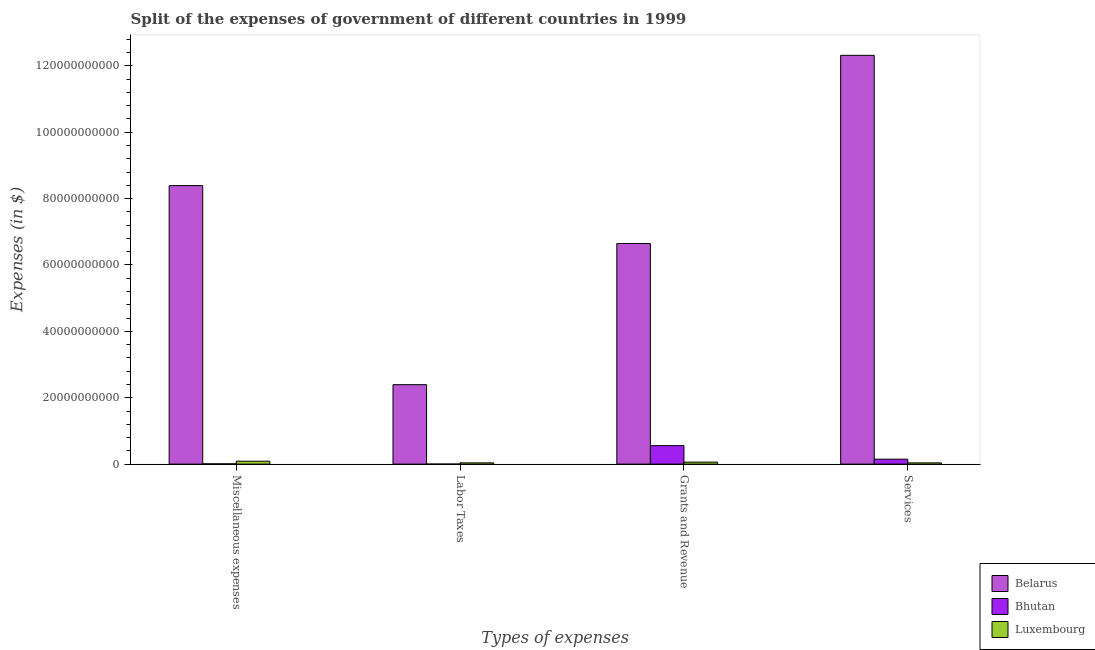How many groups of bars are there?
Provide a short and direct response. 4. Are the number of bars on each tick of the X-axis equal?
Make the answer very short. Yes. What is the label of the 2nd group of bars from the left?
Your answer should be very brief. Labor Taxes. What is the amount spent on grants and revenue in Luxembourg?
Ensure brevity in your answer.  5.98e+08. Across all countries, what is the maximum amount spent on labor taxes?
Keep it short and to the point. 2.39e+1. Across all countries, what is the minimum amount spent on grants and revenue?
Your response must be concise. 5.98e+08. In which country was the amount spent on labor taxes maximum?
Ensure brevity in your answer.  Belarus. In which country was the amount spent on grants and revenue minimum?
Ensure brevity in your answer.  Luxembourg. What is the total amount spent on services in the graph?
Offer a terse response. 1.25e+11. What is the difference between the amount spent on services in Belarus and that in Bhutan?
Keep it short and to the point. 1.22e+11. What is the difference between the amount spent on miscellaneous expenses in Bhutan and the amount spent on labor taxes in Luxembourg?
Make the answer very short. -2.91e+08. What is the average amount spent on labor taxes per country?
Offer a very short reply. 8.11e+09. What is the difference between the amount spent on grants and revenue and amount spent on miscellaneous expenses in Luxembourg?
Ensure brevity in your answer.  -2.79e+08. In how many countries, is the amount spent on labor taxes greater than 52000000000 $?
Your answer should be compact. 0. What is the ratio of the amount spent on miscellaneous expenses in Bhutan to that in Luxembourg?
Provide a short and direct response. 0.1. Is the amount spent on miscellaneous expenses in Luxembourg less than that in Belarus?
Make the answer very short. Yes. What is the difference between the highest and the second highest amount spent on labor taxes?
Your answer should be very brief. 2.36e+1. What is the difference between the highest and the lowest amount spent on miscellaneous expenses?
Your answer should be very brief. 8.38e+1. In how many countries, is the amount spent on grants and revenue greater than the average amount spent on grants and revenue taken over all countries?
Provide a succinct answer. 1. Is the sum of the amount spent on grants and revenue in Bhutan and Belarus greater than the maximum amount spent on services across all countries?
Make the answer very short. No. What does the 1st bar from the left in Miscellaneous expenses represents?
Offer a terse response. Belarus. What does the 2nd bar from the right in Grants and Revenue represents?
Offer a very short reply. Bhutan. Is it the case that in every country, the sum of the amount spent on miscellaneous expenses and amount spent on labor taxes is greater than the amount spent on grants and revenue?
Offer a terse response. No. How many countries are there in the graph?
Give a very brief answer. 3. What is the difference between two consecutive major ticks on the Y-axis?
Give a very brief answer. 2.00e+1. Are the values on the major ticks of Y-axis written in scientific E-notation?
Offer a very short reply. No. Where does the legend appear in the graph?
Provide a succinct answer. Bottom right. How are the legend labels stacked?
Keep it short and to the point. Vertical. What is the title of the graph?
Give a very brief answer. Split of the expenses of government of different countries in 1999. Does "Spain" appear as one of the legend labels in the graph?
Keep it short and to the point. No. What is the label or title of the X-axis?
Your answer should be compact. Types of expenses. What is the label or title of the Y-axis?
Provide a short and direct response. Expenses (in $). What is the Expenses (in $) in Belarus in Miscellaneous expenses?
Make the answer very short. 8.39e+1. What is the Expenses (in $) in Bhutan in Miscellaneous expenses?
Give a very brief answer. 8.63e+07. What is the Expenses (in $) of Luxembourg in Miscellaneous expenses?
Make the answer very short. 8.77e+08. What is the Expenses (in $) of Belarus in Labor Taxes?
Ensure brevity in your answer.  2.39e+1. What is the Expenses (in $) of Bhutan in Labor Taxes?
Offer a very short reply. 7.10e+06. What is the Expenses (in $) in Luxembourg in Labor Taxes?
Your response must be concise. 3.77e+08. What is the Expenses (in $) of Belarus in Grants and Revenue?
Keep it short and to the point. 6.65e+1. What is the Expenses (in $) in Bhutan in Grants and Revenue?
Your response must be concise. 5.57e+09. What is the Expenses (in $) in Luxembourg in Grants and Revenue?
Make the answer very short. 5.98e+08. What is the Expenses (in $) in Belarus in Services?
Ensure brevity in your answer.  1.23e+11. What is the Expenses (in $) in Bhutan in Services?
Offer a very short reply. 1.49e+09. What is the Expenses (in $) in Luxembourg in Services?
Your answer should be compact. 3.69e+08. Across all Types of expenses, what is the maximum Expenses (in $) in Belarus?
Keep it short and to the point. 1.23e+11. Across all Types of expenses, what is the maximum Expenses (in $) of Bhutan?
Provide a short and direct response. 5.57e+09. Across all Types of expenses, what is the maximum Expenses (in $) in Luxembourg?
Ensure brevity in your answer.  8.77e+08. Across all Types of expenses, what is the minimum Expenses (in $) of Belarus?
Ensure brevity in your answer.  2.39e+1. Across all Types of expenses, what is the minimum Expenses (in $) of Bhutan?
Your answer should be compact. 7.10e+06. Across all Types of expenses, what is the minimum Expenses (in $) of Luxembourg?
Offer a terse response. 3.69e+08. What is the total Expenses (in $) in Belarus in the graph?
Your response must be concise. 2.97e+11. What is the total Expenses (in $) of Bhutan in the graph?
Ensure brevity in your answer.  7.15e+09. What is the total Expenses (in $) in Luxembourg in the graph?
Offer a very short reply. 2.22e+09. What is the difference between the Expenses (in $) of Belarus in Miscellaneous expenses and that in Labor Taxes?
Make the answer very short. 6.00e+1. What is the difference between the Expenses (in $) in Bhutan in Miscellaneous expenses and that in Labor Taxes?
Your response must be concise. 7.92e+07. What is the difference between the Expenses (in $) in Luxembourg in Miscellaneous expenses and that in Labor Taxes?
Make the answer very short. 5.00e+08. What is the difference between the Expenses (in $) in Belarus in Miscellaneous expenses and that in Grants and Revenue?
Make the answer very short. 1.74e+1. What is the difference between the Expenses (in $) in Bhutan in Miscellaneous expenses and that in Grants and Revenue?
Your answer should be very brief. -5.48e+09. What is the difference between the Expenses (in $) in Luxembourg in Miscellaneous expenses and that in Grants and Revenue?
Provide a short and direct response. 2.79e+08. What is the difference between the Expenses (in $) of Belarus in Miscellaneous expenses and that in Services?
Provide a short and direct response. -3.93e+1. What is the difference between the Expenses (in $) in Bhutan in Miscellaneous expenses and that in Services?
Ensure brevity in your answer.  -1.40e+09. What is the difference between the Expenses (in $) of Luxembourg in Miscellaneous expenses and that in Services?
Ensure brevity in your answer.  5.08e+08. What is the difference between the Expenses (in $) of Belarus in Labor Taxes and that in Grants and Revenue?
Your answer should be compact. -4.25e+1. What is the difference between the Expenses (in $) of Bhutan in Labor Taxes and that in Grants and Revenue?
Your answer should be very brief. -5.56e+09. What is the difference between the Expenses (in $) of Luxembourg in Labor Taxes and that in Grants and Revenue?
Your response must be concise. -2.21e+08. What is the difference between the Expenses (in $) of Belarus in Labor Taxes and that in Services?
Your response must be concise. -9.92e+1. What is the difference between the Expenses (in $) of Bhutan in Labor Taxes and that in Services?
Give a very brief answer. -1.48e+09. What is the difference between the Expenses (in $) in Luxembourg in Labor Taxes and that in Services?
Ensure brevity in your answer.  7.75e+06. What is the difference between the Expenses (in $) in Belarus in Grants and Revenue and that in Services?
Give a very brief answer. -5.67e+1. What is the difference between the Expenses (in $) in Bhutan in Grants and Revenue and that in Services?
Your answer should be very brief. 4.08e+09. What is the difference between the Expenses (in $) in Luxembourg in Grants and Revenue and that in Services?
Your answer should be compact. 2.29e+08. What is the difference between the Expenses (in $) of Belarus in Miscellaneous expenses and the Expenses (in $) of Bhutan in Labor Taxes?
Provide a succinct answer. 8.39e+1. What is the difference between the Expenses (in $) of Belarus in Miscellaneous expenses and the Expenses (in $) of Luxembourg in Labor Taxes?
Provide a short and direct response. 8.35e+1. What is the difference between the Expenses (in $) of Bhutan in Miscellaneous expenses and the Expenses (in $) of Luxembourg in Labor Taxes?
Give a very brief answer. -2.91e+08. What is the difference between the Expenses (in $) in Belarus in Miscellaneous expenses and the Expenses (in $) in Bhutan in Grants and Revenue?
Ensure brevity in your answer.  7.83e+1. What is the difference between the Expenses (in $) in Belarus in Miscellaneous expenses and the Expenses (in $) in Luxembourg in Grants and Revenue?
Offer a very short reply. 8.33e+1. What is the difference between the Expenses (in $) of Bhutan in Miscellaneous expenses and the Expenses (in $) of Luxembourg in Grants and Revenue?
Your answer should be compact. -5.12e+08. What is the difference between the Expenses (in $) of Belarus in Miscellaneous expenses and the Expenses (in $) of Bhutan in Services?
Offer a terse response. 8.24e+1. What is the difference between the Expenses (in $) of Belarus in Miscellaneous expenses and the Expenses (in $) of Luxembourg in Services?
Your response must be concise. 8.35e+1. What is the difference between the Expenses (in $) in Bhutan in Miscellaneous expenses and the Expenses (in $) in Luxembourg in Services?
Offer a very short reply. -2.83e+08. What is the difference between the Expenses (in $) of Belarus in Labor Taxes and the Expenses (in $) of Bhutan in Grants and Revenue?
Your response must be concise. 1.84e+1. What is the difference between the Expenses (in $) of Belarus in Labor Taxes and the Expenses (in $) of Luxembourg in Grants and Revenue?
Offer a terse response. 2.33e+1. What is the difference between the Expenses (in $) of Bhutan in Labor Taxes and the Expenses (in $) of Luxembourg in Grants and Revenue?
Keep it short and to the point. -5.91e+08. What is the difference between the Expenses (in $) of Belarus in Labor Taxes and the Expenses (in $) of Bhutan in Services?
Your response must be concise. 2.24e+1. What is the difference between the Expenses (in $) in Belarus in Labor Taxes and the Expenses (in $) in Luxembourg in Services?
Provide a succinct answer. 2.36e+1. What is the difference between the Expenses (in $) of Bhutan in Labor Taxes and the Expenses (in $) of Luxembourg in Services?
Offer a very short reply. -3.62e+08. What is the difference between the Expenses (in $) of Belarus in Grants and Revenue and the Expenses (in $) of Bhutan in Services?
Make the answer very short. 6.50e+1. What is the difference between the Expenses (in $) of Belarus in Grants and Revenue and the Expenses (in $) of Luxembourg in Services?
Offer a very short reply. 6.61e+1. What is the difference between the Expenses (in $) in Bhutan in Grants and Revenue and the Expenses (in $) in Luxembourg in Services?
Offer a very short reply. 5.20e+09. What is the average Expenses (in $) of Belarus per Types of expenses?
Your answer should be very brief. 7.44e+1. What is the average Expenses (in $) of Bhutan per Types of expenses?
Your response must be concise. 1.79e+09. What is the average Expenses (in $) in Luxembourg per Types of expenses?
Ensure brevity in your answer.  5.55e+08. What is the difference between the Expenses (in $) in Belarus and Expenses (in $) in Bhutan in Miscellaneous expenses?
Your response must be concise. 8.38e+1. What is the difference between the Expenses (in $) in Belarus and Expenses (in $) in Luxembourg in Miscellaneous expenses?
Keep it short and to the point. 8.30e+1. What is the difference between the Expenses (in $) of Bhutan and Expenses (in $) of Luxembourg in Miscellaneous expenses?
Your response must be concise. -7.90e+08. What is the difference between the Expenses (in $) in Belarus and Expenses (in $) in Bhutan in Labor Taxes?
Offer a terse response. 2.39e+1. What is the difference between the Expenses (in $) in Belarus and Expenses (in $) in Luxembourg in Labor Taxes?
Provide a succinct answer. 2.36e+1. What is the difference between the Expenses (in $) of Bhutan and Expenses (in $) of Luxembourg in Labor Taxes?
Your answer should be compact. -3.70e+08. What is the difference between the Expenses (in $) in Belarus and Expenses (in $) in Bhutan in Grants and Revenue?
Ensure brevity in your answer.  6.09e+1. What is the difference between the Expenses (in $) of Belarus and Expenses (in $) of Luxembourg in Grants and Revenue?
Provide a short and direct response. 6.59e+1. What is the difference between the Expenses (in $) in Bhutan and Expenses (in $) in Luxembourg in Grants and Revenue?
Provide a short and direct response. 4.97e+09. What is the difference between the Expenses (in $) of Belarus and Expenses (in $) of Bhutan in Services?
Ensure brevity in your answer.  1.22e+11. What is the difference between the Expenses (in $) in Belarus and Expenses (in $) in Luxembourg in Services?
Provide a short and direct response. 1.23e+11. What is the difference between the Expenses (in $) in Bhutan and Expenses (in $) in Luxembourg in Services?
Provide a succinct answer. 1.12e+09. What is the ratio of the Expenses (in $) of Belarus in Miscellaneous expenses to that in Labor Taxes?
Your answer should be very brief. 3.51. What is the ratio of the Expenses (in $) in Bhutan in Miscellaneous expenses to that in Labor Taxes?
Give a very brief answer. 12.15. What is the ratio of the Expenses (in $) of Luxembourg in Miscellaneous expenses to that in Labor Taxes?
Your answer should be very brief. 2.33. What is the ratio of the Expenses (in $) in Belarus in Miscellaneous expenses to that in Grants and Revenue?
Offer a terse response. 1.26. What is the ratio of the Expenses (in $) in Bhutan in Miscellaneous expenses to that in Grants and Revenue?
Your response must be concise. 0.02. What is the ratio of the Expenses (in $) in Luxembourg in Miscellaneous expenses to that in Grants and Revenue?
Keep it short and to the point. 1.47. What is the ratio of the Expenses (in $) of Belarus in Miscellaneous expenses to that in Services?
Keep it short and to the point. 0.68. What is the ratio of the Expenses (in $) in Bhutan in Miscellaneous expenses to that in Services?
Your response must be concise. 0.06. What is the ratio of the Expenses (in $) in Luxembourg in Miscellaneous expenses to that in Services?
Your answer should be compact. 2.38. What is the ratio of the Expenses (in $) of Belarus in Labor Taxes to that in Grants and Revenue?
Offer a very short reply. 0.36. What is the ratio of the Expenses (in $) of Bhutan in Labor Taxes to that in Grants and Revenue?
Keep it short and to the point. 0. What is the ratio of the Expenses (in $) in Luxembourg in Labor Taxes to that in Grants and Revenue?
Your answer should be compact. 0.63. What is the ratio of the Expenses (in $) in Belarus in Labor Taxes to that in Services?
Give a very brief answer. 0.19. What is the ratio of the Expenses (in $) of Bhutan in Labor Taxes to that in Services?
Provide a short and direct response. 0. What is the ratio of the Expenses (in $) in Belarus in Grants and Revenue to that in Services?
Give a very brief answer. 0.54. What is the ratio of the Expenses (in $) of Bhutan in Grants and Revenue to that in Services?
Give a very brief answer. 3.75. What is the ratio of the Expenses (in $) of Luxembourg in Grants and Revenue to that in Services?
Offer a terse response. 1.62. What is the difference between the highest and the second highest Expenses (in $) of Belarus?
Your response must be concise. 3.93e+1. What is the difference between the highest and the second highest Expenses (in $) in Bhutan?
Your answer should be very brief. 4.08e+09. What is the difference between the highest and the second highest Expenses (in $) in Luxembourg?
Ensure brevity in your answer.  2.79e+08. What is the difference between the highest and the lowest Expenses (in $) of Belarus?
Keep it short and to the point. 9.92e+1. What is the difference between the highest and the lowest Expenses (in $) of Bhutan?
Ensure brevity in your answer.  5.56e+09. What is the difference between the highest and the lowest Expenses (in $) in Luxembourg?
Ensure brevity in your answer.  5.08e+08. 